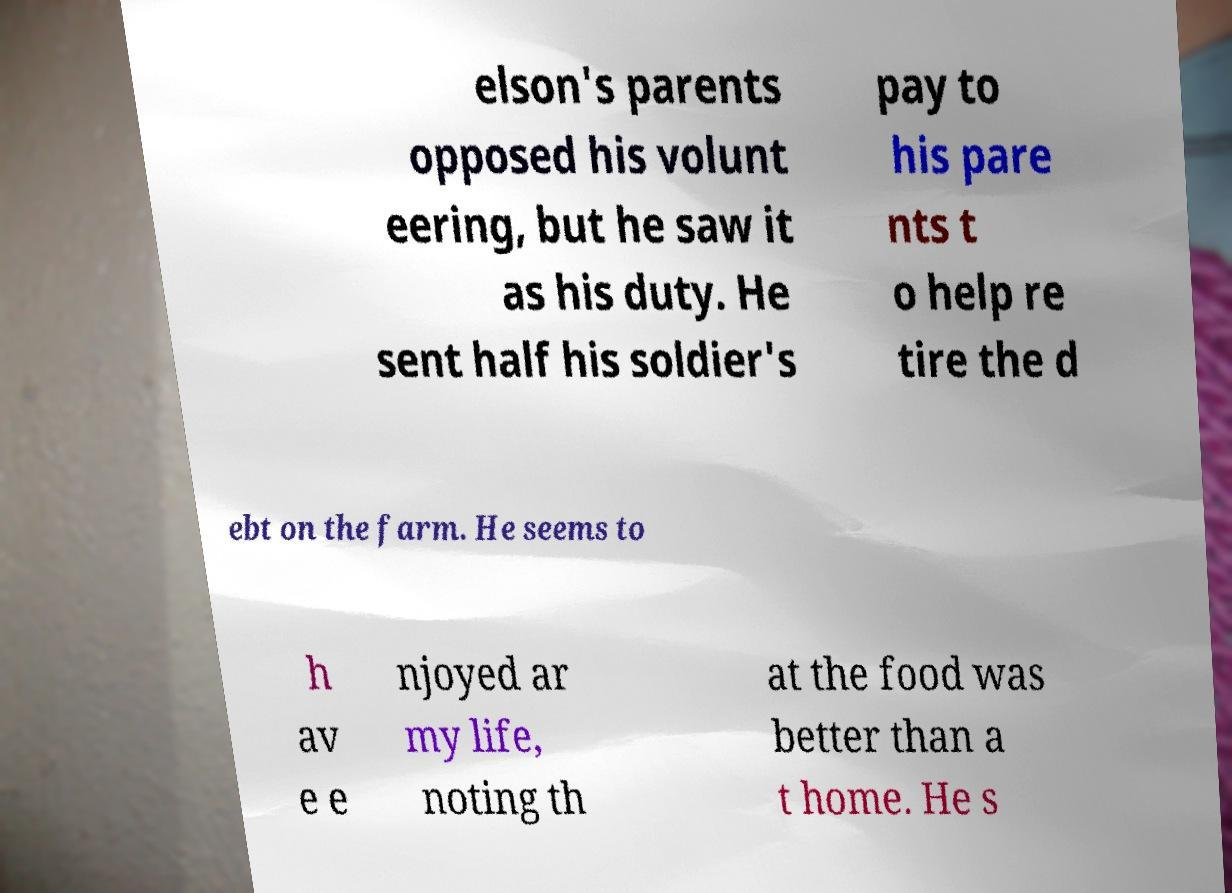I need the written content from this picture converted into text. Can you do that? elson's parents opposed his volunt eering, but he saw it as his duty. He sent half his soldier's pay to his pare nts t o help re tire the d ebt on the farm. He seems to h av e e njoyed ar my life, noting th at the food was better than a t home. He s 